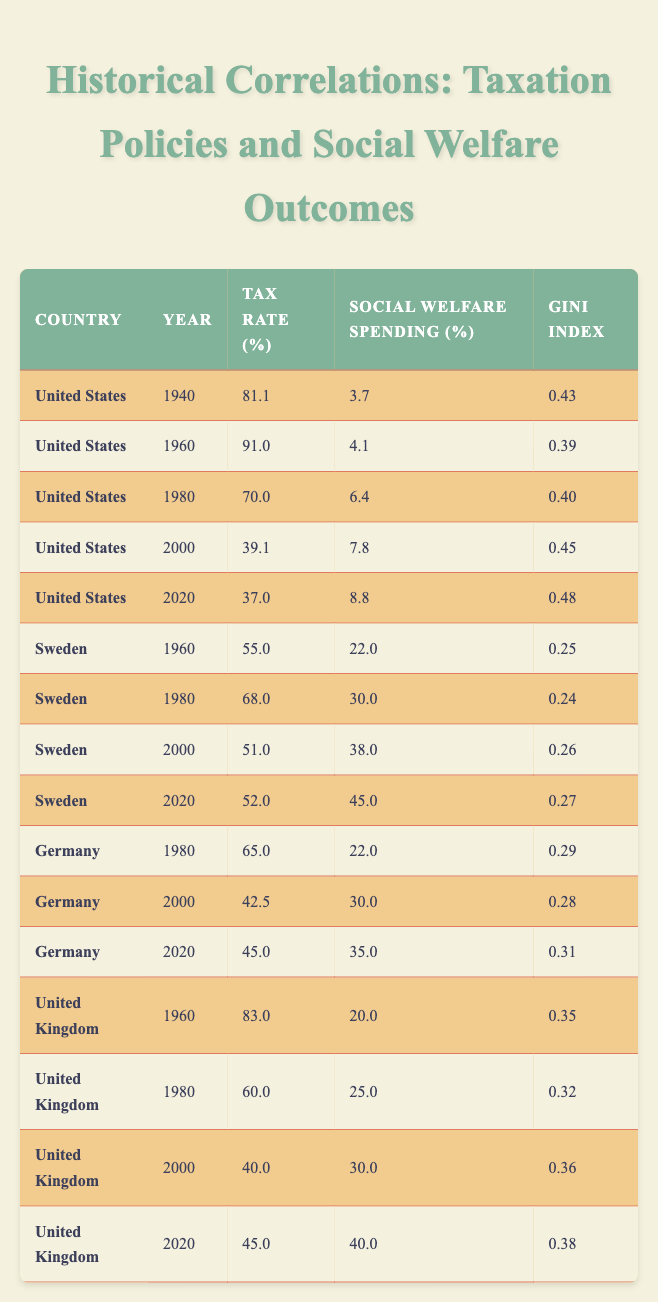What is the highest tax rate listed in the table? The highest tax rate is found in the United States in 1960, where the tax rate is 91.0%.
Answer: 91.0 Which country had the lowest Gini index and in which year? Sweden had the lowest Gini index of 0.24 in 1980.
Answer: 0.24 in 1980 What was the average social welfare spending in Sweden from 1960 to 2020? The social welfare spending values are 22.0, 30.0, 38.0, and 45.0. To find the average, we add them (22.0 + 30.0 + 38.0 + 45.0) = 135.0 and divide by the number of data points, which is 4. Thus, the average is 135.0 / 4 = 33.75.
Answer: 33.75 Did the tax rate in the United Kingdom increase or decrease from 1960 to 2020? In 1960, the UK tax rate was 83.0%, and in 2020 it was 45.0%, indicating a decrease over that period.
Answer: Decrease What correlation can you observe between the tax rates and the Gini index in the United States from 1940 to 2020? The Gini index tends to increase as the tax rate decreases over time. In 1940, with a tax rate of 81.1%, the Gini index was 0.43, and it rose to 0.48 by 2020 when the tax rate fell to 37.0%.
Answer: Positive correlation What was the difference in social welfare spending between 2000 and 2020 for the United States? The social welfare spending for the United States in 2000 was 7.8% and in 2020 it was 8.8%. The difference is 8.8 - 7.8 = 1.0%.
Answer: 1.0% Was the Gini index for Germany in 2000 lower than that of the United Kingdom in the same year? In 2000, the Gini index for Germany was 0.28 while the index for the United Kingdom was 0.36, making Germany's Gini index lower.
Answer: Yes What is the trend observed in tax rates in Sweden from 1960 to 2020? The tax rate in Sweden shows an initial increase from 55.0% in 1960 to 68.0% in 1980, followed by a decrease to 51.0% in 2000 and slight change to 52.0% in 2020. Overall, the trend shows an initial rise followed by stabilization.
Answer: Rise then stabilize 